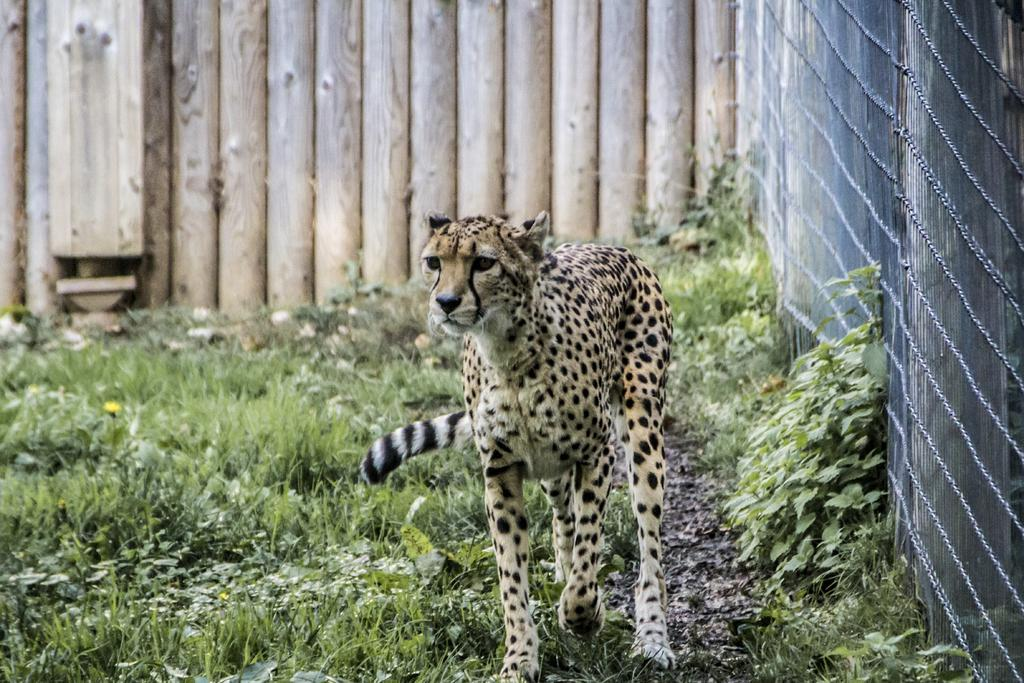What animal is the main subject of the picture? There is a leopard in the picture. What can be seen beside the leopard? There are plants beside the leopard. What is the purpose of the structure in the picture? There is a fence in the picture, which may serve as a barrier or boundary. What type of operation is being performed on the leopard in the image? There is no operation being performed on the leopard in the image; it is simply standing beside the plants. How much sand can be seen in the image? There is no sand present in the image. 